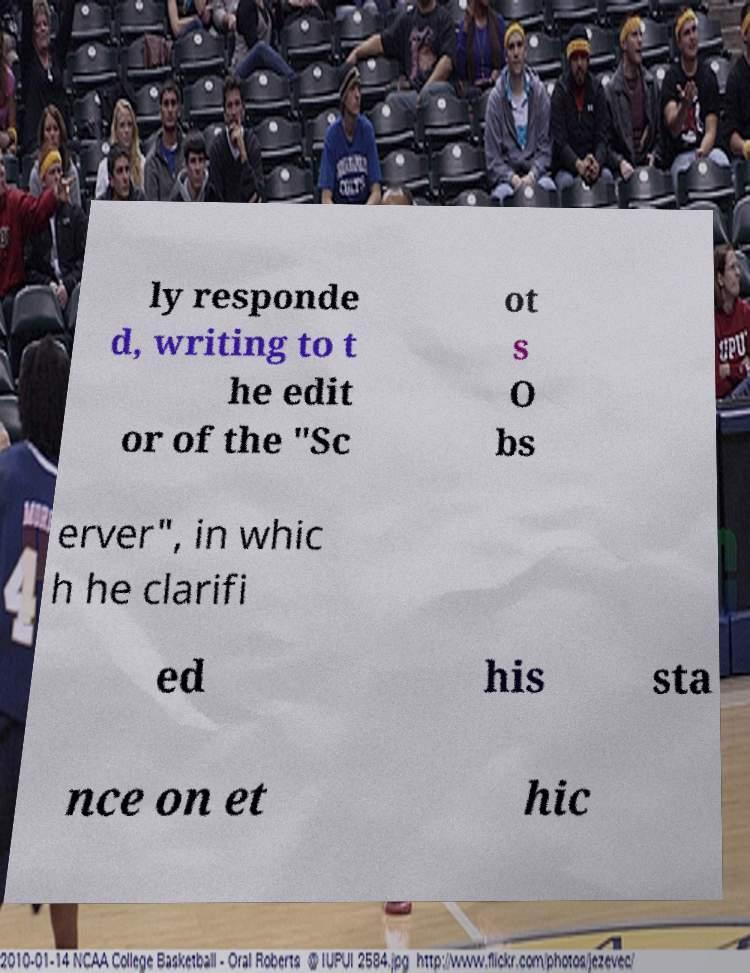I need the written content from this picture converted into text. Can you do that? ly responde d, writing to t he edit or of the "Sc ot s O bs erver", in whic h he clarifi ed his sta nce on et hic 